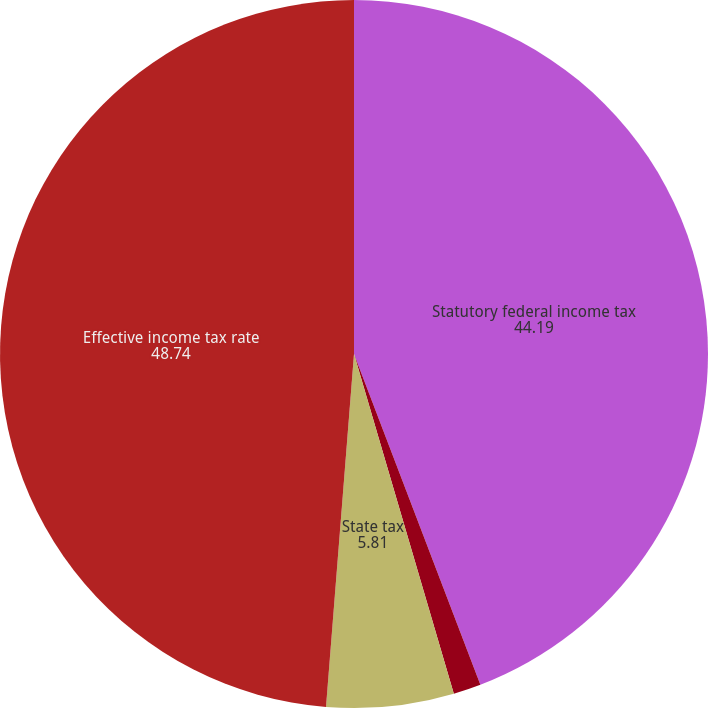<chart> <loc_0><loc_0><loc_500><loc_500><pie_chart><fcel>Statutory federal income tax<fcel>Amortization of investment tax<fcel>State tax<fcel>Effective income tax rate<nl><fcel>44.19%<fcel>1.26%<fcel>5.81%<fcel>48.74%<nl></chart> 